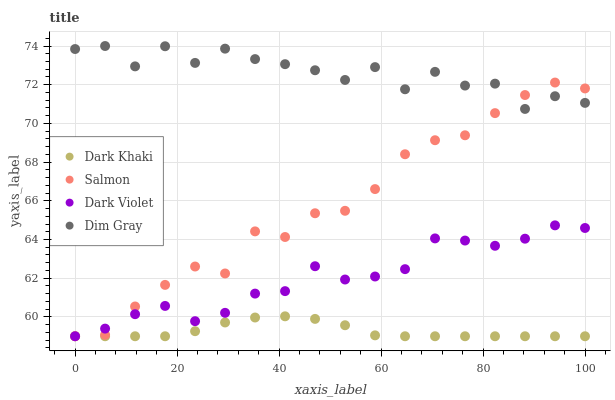Does Dark Khaki have the minimum area under the curve?
Answer yes or no. Yes. Does Dim Gray have the maximum area under the curve?
Answer yes or no. Yes. Does Salmon have the minimum area under the curve?
Answer yes or no. No. Does Salmon have the maximum area under the curve?
Answer yes or no. No. Is Dark Khaki the smoothest?
Answer yes or no. Yes. Is Dim Gray the roughest?
Answer yes or no. Yes. Is Salmon the smoothest?
Answer yes or no. No. Is Salmon the roughest?
Answer yes or no. No. Does Dark Khaki have the lowest value?
Answer yes or no. Yes. Does Dim Gray have the lowest value?
Answer yes or no. No. Does Dim Gray have the highest value?
Answer yes or no. Yes. Does Salmon have the highest value?
Answer yes or no. No. Is Dark Violet less than Dim Gray?
Answer yes or no. Yes. Is Dim Gray greater than Dark Khaki?
Answer yes or no. Yes. Does Dim Gray intersect Salmon?
Answer yes or no. Yes. Is Dim Gray less than Salmon?
Answer yes or no. No. Is Dim Gray greater than Salmon?
Answer yes or no. No. Does Dark Violet intersect Dim Gray?
Answer yes or no. No. 